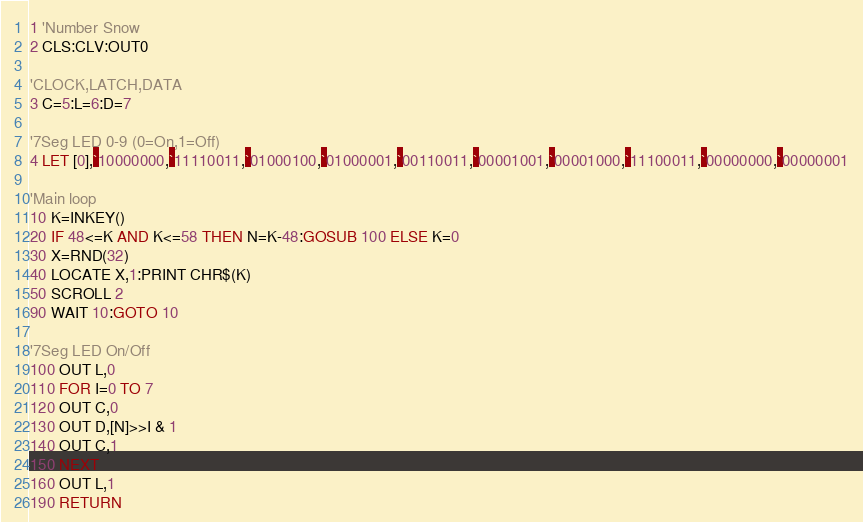Convert code to text. <code><loc_0><loc_0><loc_500><loc_500><_VisualBasic_>1 'Number Snow
2 CLS:CLV:OUT0

'CLOCK,LATCH,DATA
3 C=5:L=6:D=7

'7Seg LED 0-9 (0=On,1=Off)
4 LET [0],`10000000,`11110011,`01000100,`01000001,`00110011,`00001001,`00001000,`11100011,`00000000,`00000001

'Main loop
10 K=INKEY()
20 IF 48<=K AND K<=58 THEN N=K-48:GOSUB 100 ELSE K=0
30 X=RND(32)
40 LOCATE X,1:PRINT CHR$(K)
50 SCROLL 2
90 WAIT 10:GOTO 10

'7Seg LED On/Off
100 OUT L,0
110 FOR I=0 TO 7
120 OUT C,0
130 OUT D,[N]>>I & 1
140 OUT C,1
150 NEXT
160 OUT L,1
190 RETURN</code> 